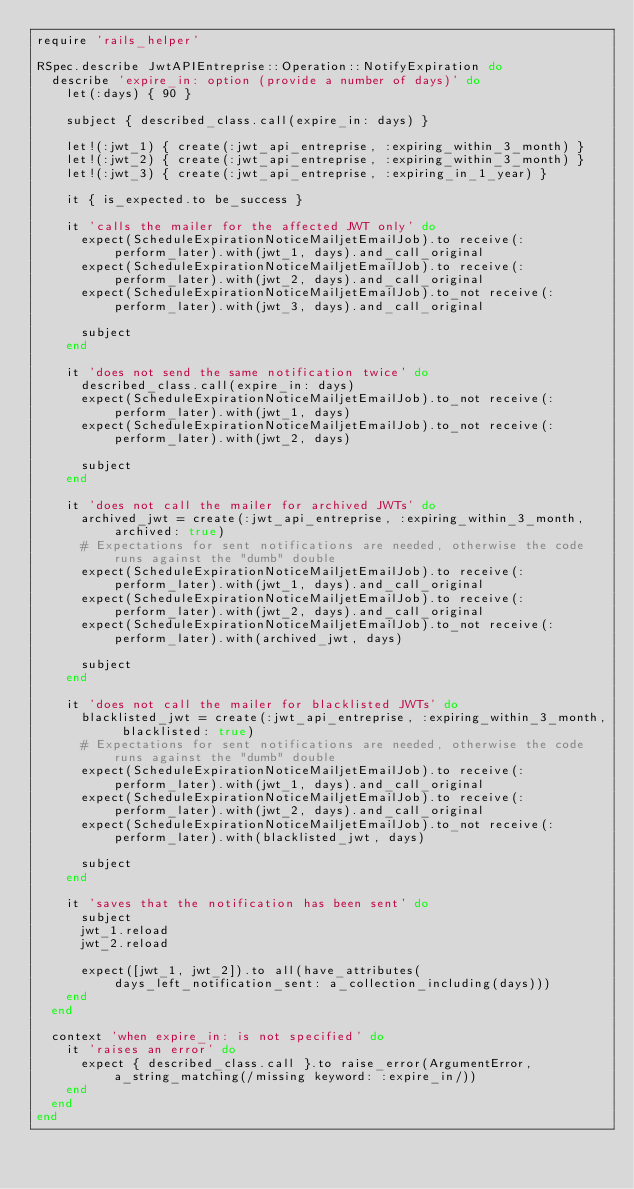Convert code to text. <code><loc_0><loc_0><loc_500><loc_500><_Ruby_>require 'rails_helper'

RSpec.describe JwtAPIEntreprise::Operation::NotifyExpiration do
  describe 'expire_in: option (provide a number of days)' do
    let(:days) { 90 }

    subject { described_class.call(expire_in: days) }

    let!(:jwt_1) { create(:jwt_api_entreprise, :expiring_within_3_month) }
    let!(:jwt_2) { create(:jwt_api_entreprise, :expiring_within_3_month) }
    let!(:jwt_3) { create(:jwt_api_entreprise, :expiring_in_1_year) }

    it { is_expected.to be_success }

    it 'calls the mailer for the affected JWT only' do
      expect(ScheduleExpirationNoticeMailjetEmailJob).to receive(:perform_later).with(jwt_1, days).and_call_original
      expect(ScheduleExpirationNoticeMailjetEmailJob).to receive(:perform_later).with(jwt_2, days).and_call_original
      expect(ScheduleExpirationNoticeMailjetEmailJob).to_not receive(:perform_later).with(jwt_3, days).and_call_original

      subject
    end

    it 'does not send the same notification twice' do
      described_class.call(expire_in: days)
      expect(ScheduleExpirationNoticeMailjetEmailJob).to_not receive(:perform_later).with(jwt_1, days)
      expect(ScheduleExpirationNoticeMailjetEmailJob).to_not receive(:perform_later).with(jwt_2, days)

      subject
    end

    it 'does not call the mailer for archived JWTs' do
      archived_jwt = create(:jwt_api_entreprise, :expiring_within_3_month, archived: true)
      # Expectations for sent notifications are needed, otherwise the code runs against the "dumb" double
      expect(ScheduleExpirationNoticeMailjetEmailJob).to receive(:perform_later).with(jwt_1, days).and_call_original
      expect(ScheduleExpirationNoticeMailjetEmailJob).to receive(:perform_later).with(jwt_2, days).and_call_original
      expect(ScheduleExpirationNoticeMailjetEmailJob).to_not receive(:perform_later).with(archived_jwt, days)

      subject
    end

    it 'does not call the mailer for blacklisted JWTs' do
      blacklisted_jwt = create(:jwt_api_entreprise, :expiring_within_3_month, blacklisted: true)
      # Expectations for sent notifications are needed, otherwise the code runs against the "dumb" double
      expect(ScheduleExpirationNoticeMailjetEmailJob).to receive(:perform_later).with(jwt_1, days).and_call_original
      expect(ScheduleExpirationNoticeMailjetEmailJob).to receive(:perform_later).with(jwt_2, days).and_call_original
      expect(ScheduleExpirationNoticeMailjetEmailJob).to_not receive(:perform_later).with(blacklisted_jwt, days)

      subject
    end

    it 'saves that the notification has been sent' do
      subject
      jwt_1.reload
      jwt_2.reload

      expect([jwt_1, jwt_2]).to all(have_attributes(days_left_notification_sent: a_collection_including(days)))
    end
  end

  context 'when expire_in: is not specified' do
    it 'raises an error' do
      expect { described_class.call }.to raise_error(ArgumentError, a_string_matching(/missing keyword: :expire_in/))
    end
  end
end
</code> 